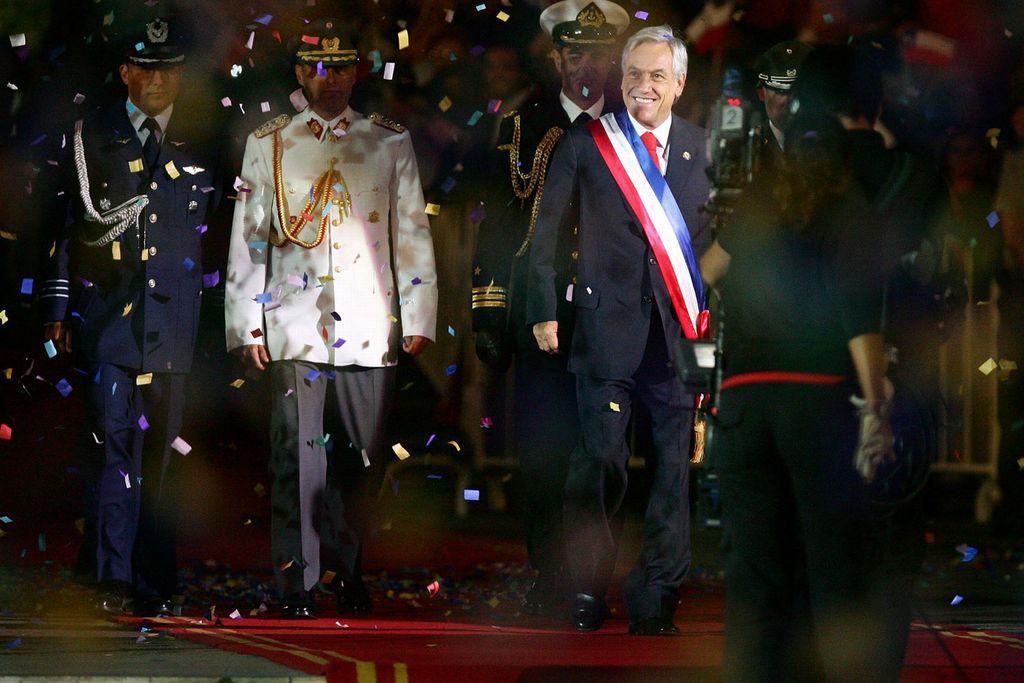Describe this image in one or two sentences. In this image we can see few people standing on a red carpet, there is a camera in front of them and a person is holding a white color object and there are paper on air. 